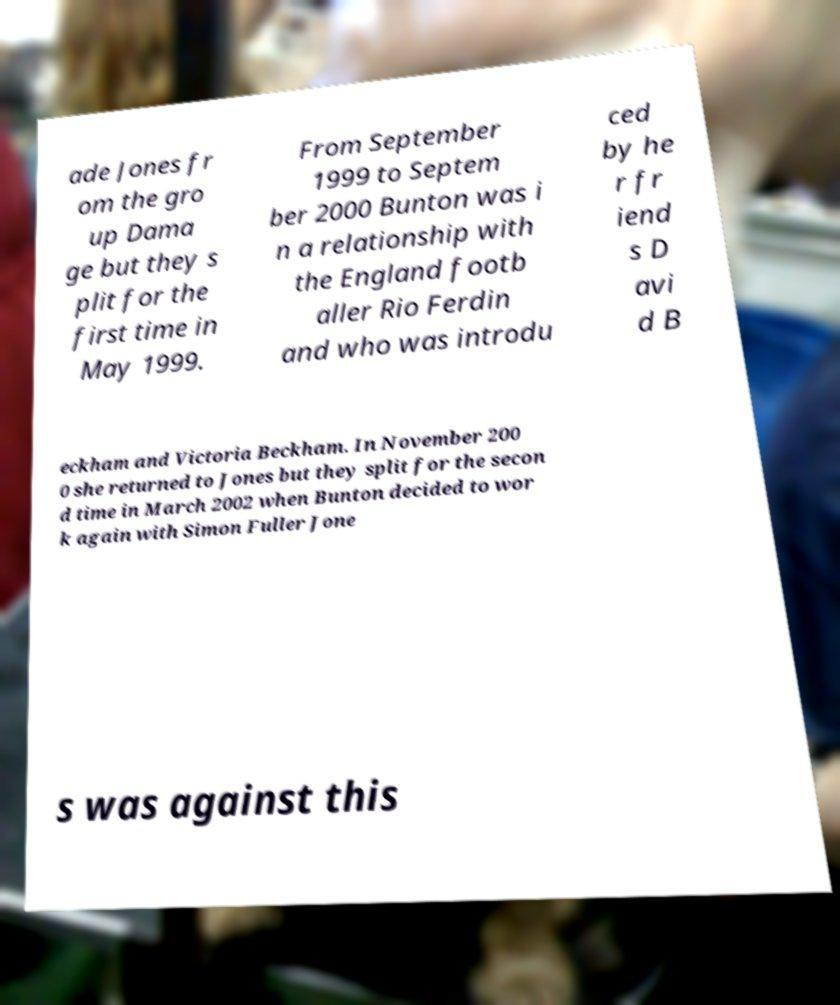Please read and relay the text visible in this image. What does it say? ade Jones fr om the gro up Dama ge but they s plit for the first time in May 1999. From September 1999 to Septem ber 2000 Bunton was i n a relationship with the England footb aller Rio Ferdin and who was introdu ced by he r fr iend s D avi d B eckham and Victoria Beckham. In November 200 0 she returned to Jones but they split for the secon d time in March 2002 when Bunton decided to wor k again with Simon Fuller Jone s was against this 